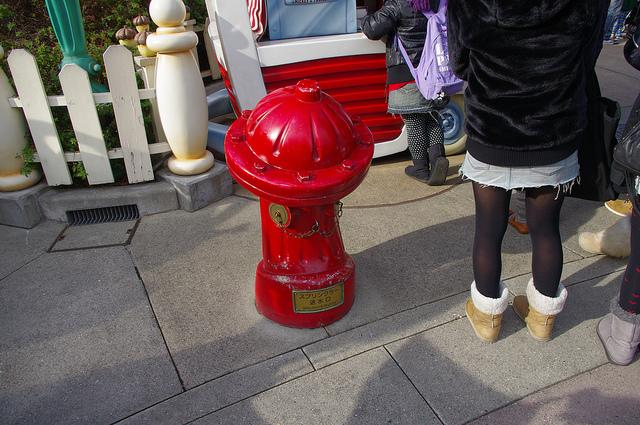What is required to open the flow of water? wrench 